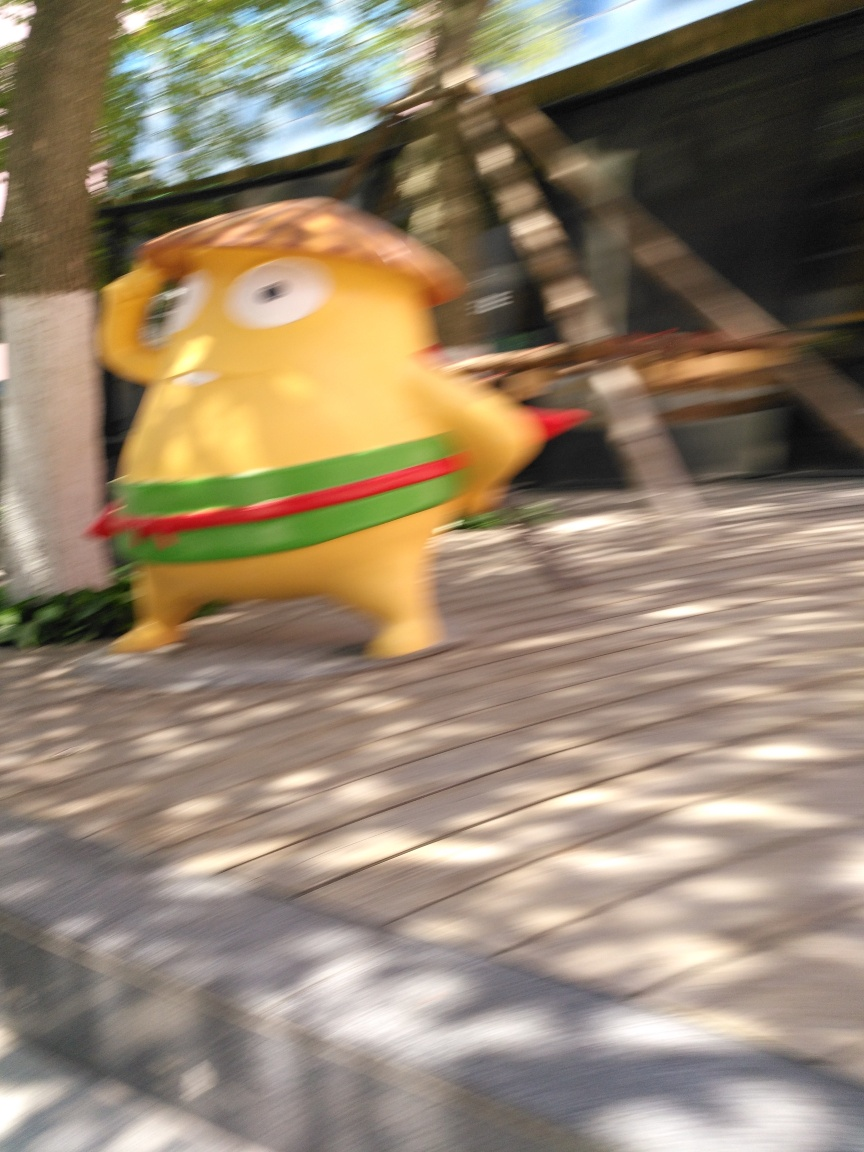Can you describe the character in the image? Certainly! The character appears to be an anthropomorphized, cartoon-style figure with an oblong shape and exaggerated features. It has a cheerful expression and seems to be depicted mid-movement, enhancing the dynamic and playful atmosphere of the scene. 